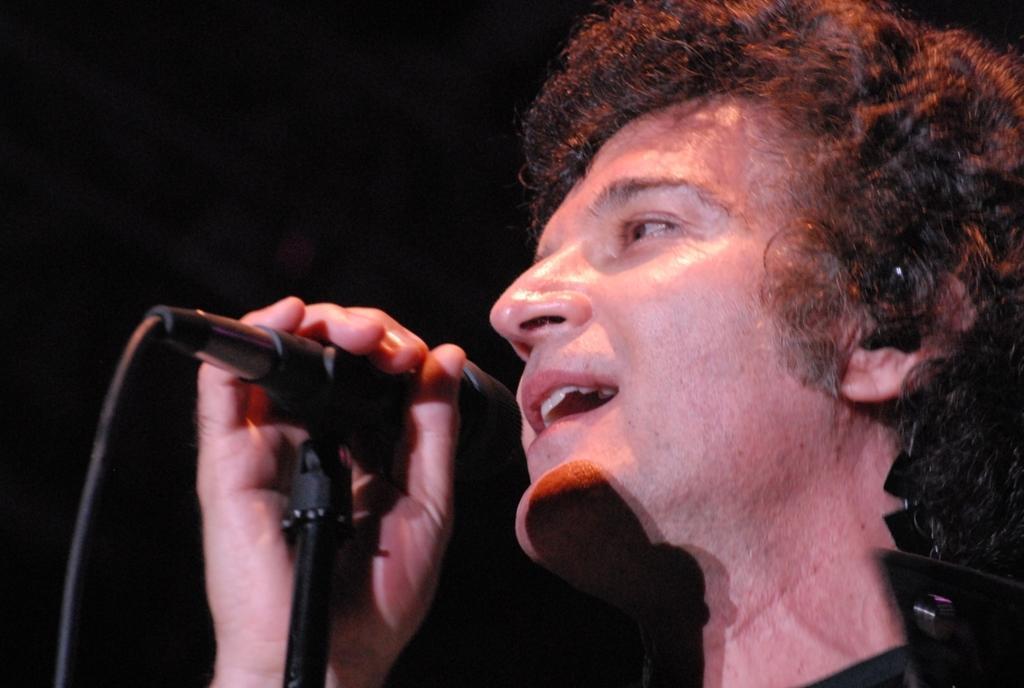How would you summarize this image in a sentence or two? In this image there is a man and he is singing on a mic. The background is dark. 